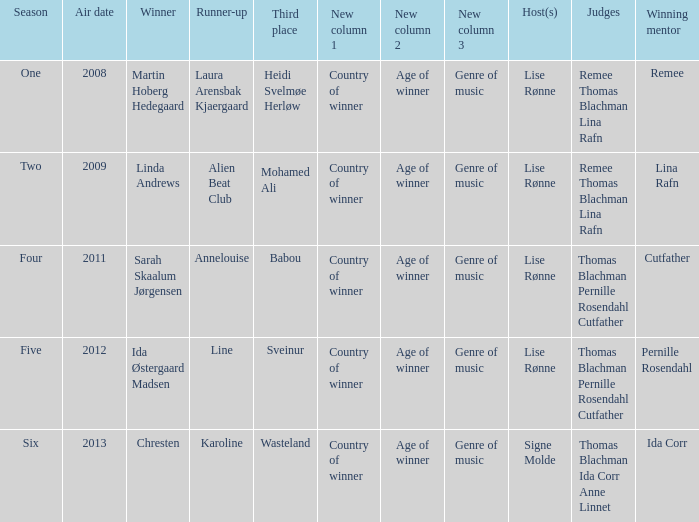Who was the runner-up in season five? Line. 